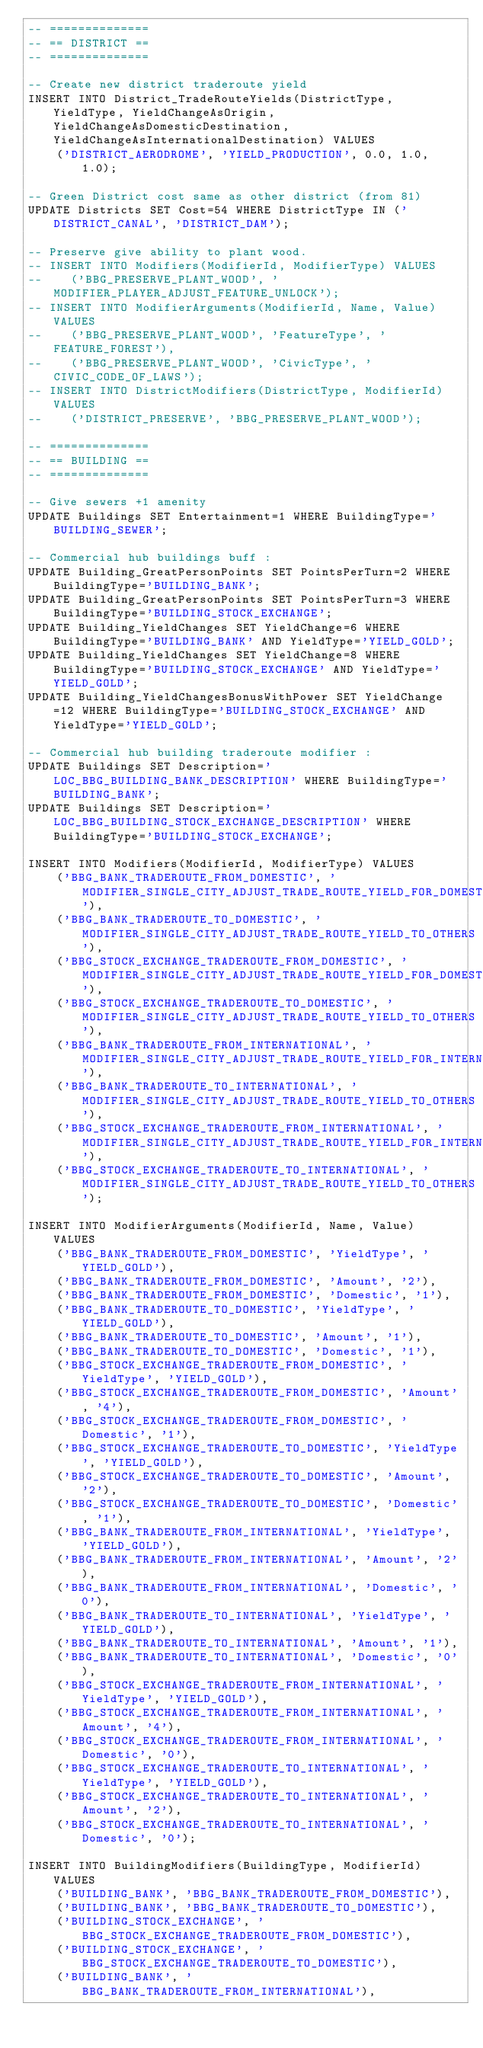<code> <loc_0><loc_0><loc_500><loc_500><_SQL_>-- ==============
-- == DISTRICT ==
-- ==============

-- Create new district traderoute yield
INSERT INTO District_TradeRouteYields(DistrictType, YieldType, YieldChangeAsOrigin, YieldChangeAsDomesticDestination, YieldChangeAsInternationalDestination) VALUES
    ('DISTRICT_AERODROME', 'YIELD_PRODUCTION', 0.0, 1.0, 1.0);

-- Green District cost same as other district (from 81)
UPDATE Districts SET Cost=54 WHERE DistrictType IN ('DISTRICT_CANAL', 'DISTRICT_DAM');

-- Preserve give ability to plant wood.
-- INSERT INTO Modifiers(ModifierId, ModifierType) VALUES
--    ('BBG_PRESERVE_PLANT_WOOD', 'MODIFIER_PLAYER_ADJUST_FEATURE_UNLOCK');
-- INSERT INTO ModifierArguments(ModifierId, Name, Value) VALUES
--    ('BBG_PRESERVE_PLANT_WOOD', 'FeatureType', 'FEATURE_FOREST'),
--    ('BBG_PRESERVE_PLANT_WOOD', 'CivicType', 'CIVIC_CODE_OF_LAWS');
-- INSERT INTO DistrictModifiers(DistrictType, ModifierId) VALUES
--    ('DISTRICT_PRESERVE', 'BBG_PRESERVE_PLANT_WOOD');

-- ==============
-- == BUILDING ==
-- ==============

-- Give sewers +1 amenity
UPDATE Buildings SET Entertainment=1 WHERE BuildingType='BUILDING_SEWER';

-- Commercial hub buildings buff :
UPDATE Building_GreatPersonPoints SET PointsPerTurn=2 WHERE BuildingType='BUILDING_BANK';
UPDATE Building_GreatPersonPoints SET PointsPerTurn=3 WHERE BuildingType='BUILDING_STOCK_EXCHANGE';
UPDATE Building_YieldChanges SET YieldChange=6 WHERE BuildingType='BUILDING_BANK' AND YieldType='YIELD_GOLD';
UPDATE Building_YieldChanges SET YieldChange=8 WHERE BuildingType='BUILDING_STOCK_EXCHANGE' AND YieldType='YIELD_GOLD';
UPDATE Building_YieldChangesBonusWithPower SET YieldChange=12 WHERE BuildingType='BUILDING_STOCK_EXCHANGE' AND YieldType='YIELD_GOLD';

-- Commercial hub building traderoute modifier :
UPDATE Buildings SET Description='LOC_BBG_BUILDING_BANK_DESCRIPTION' WHERE BuildingType='BUILDING_BANK';
UPDATE Buildings SET Description='LOC_BBG_BUILDING_STOCK_EXCHANGE_DESCRIPTION' WHERE BuildingType='BUILDING_STOCK_EXCHANGE';

INSERT INTO Modifiers(ModifierId, ModifierType) VALUES
    ('BBG_BANK_TRADEROUTE_FROM_DOMESTIC', 'MODIFIER_SINGLE_CITY_ADJUST_TRADE_ROUTE_YIELD_FOR_DOMESTIC'),
    ('BBG_BANK_TRADEROUTE_TO_DOMESTIC', 'MODIFIER_SINGLE_CITY_ADJUST_TRADE_ROUTE_YIELD_TO_OTHERS'),
    ('BBG_STOCK_EXCHANGE_TRADEROUTE_FROM_DOMESTIC', 'MODIFIER_SINGLE_CITY_ADJUST_TRADE_ROUTE_YIELD_FOR_DOMESTIC'),
    ('BBG_STOCK_EXCHANGE_TRADEROUTE_TO_DOMESTIC', 'MODIFIER_SINGLE_CITY_ADJUST_TRADE_ROUTE_YIELD_TO_OTHERS'),
    ('BBG_BANK_TRADEROUTE_FROM_INTERNATIONAL', 'MODIFIER_SINGLE_CITY_ADJUST_TRADE_ROUTE_YIELD_FOR_INTERNATIONAL'),
    ('BBG_BANK_TRADEROUTE_TO_INTERNATIONAL', 'MODIFIER_SINGLE_CITY_ADJUST_TRADE_ROUTE_YIELD_TO_OTHERS'),
    ('BBG_STOCK_EXCHANGE_TRADEROUTE_FROM_INTERNATIONAL', 'MODIFIER_SINGLE_CITY_ADJUST_TRADE_ROUTE_YIELD_FOR_INTERNATIONAL'),
    ('BBG_STOCK_EXCHANGE_TRADEROUTE_TO_INTERNATIONAL', 'MODIFIER_SINGLE_CITY_ADJUST_TRADE_ROUTE_YIELD_TO_OTHERS');

INSERT INTO ModifierArguments(ModifierId, Name, Value) VALUES
    ('BBG_BANK_TRADEROUTE_FROM_DOMESTIC', 'YieldType', 'YIELD_GOLD'),
    ('BBG_BANK_TRADEROUTE_FROM_DOMESTIC', 'Amount', '2'),
    ('BBG_BANK_TRADEROUTE_FROM_DOMESTIC', 'Domestic', '1'),
    ('BBG_BANK_TRADEROUTE_TO_DOMESTIC', 'YieldType', 'YIELD_GOLD'),
    ('BBG_BANK_TRADEROUTE_TO_DOMESTIC', 'Amount', '1'),
    ('BBG_BANK_TRADEROUTE_TO_DOMESTIC', 'Domestic', '1'),
    ('BBG_STOCK_EXCHANGE_TRADEROUTE_FROM_DOMESTIC', 'YieldType', 'YIELD_GOLD'),
    ('BBG_STOCK_EXCHANGE_TRADEROUTE_FROM_DOMESTIC', 'Amount', '4'),
    ('BBG_STOCK_EXCHANGE_TRADEROUTE_FROM_DOMESTIC', 'Domestic', '1'),
    ('BBG_STOCK_EXCHANGE_TRADEROUTE_TO_DOMESTIC', 'YieldType', 'YIELD_GOLD'),
    ('BBG_STOCK_EXCHANGE_TRADEROUTE_TO_DOMESTIC', 'Amount', '2'),
    ('BBG_STOCK_EXCHANGE_TRADEROUTE_TO_DOMESTIC', 'Domestic', '1'),
    ('BBG_BANK_TRADEROUTE_FROM_INTERNATIONAL', 'YieldType', 'YIELD_GOLD'),
    ('BBG_BANK_TRADEROUTE_FROM_INTERNATIONAL', 'Amount', '2'),
    ('BBG_BANK_TRADEROUTE_FROM_INTERNATIONAL', 'Domestic', '0'),
    ('BBG_BANK_TRADEROUTE_TO_INTERNATIONAL', 'YieldType', 'YIELD_GOLD'),
    ('BBG_BANK_TRADEROUTE_TO_INTERNATIONAL', 'Amount', '1'),
    ('BBG_BANK_TRADEROUTE_TO_INTERNATIONAL', 'Domestic', '0'),
    ('BBG_STOCK_EXCHANGE_TRADEROUTE_FROM_INTERNATIONAL', 'YieldType', 'YIELD_GOLD'),
    ('BBG_STOCK_EXCHANGE_TRADEROUTE_FROM_INTERNATIONAL', 'Amount', '4'),
    ('BBG_STOCK_EXCHANGE_TRADEROUTE_FROM_INTERNATIONAL', 'Domestic', '0'),
    ('BBG_STOCK_EXCHANGE_TRADEROUTE_TO_INTERNATIONAL', 'YieldType', 'YIELD_GOLD'),
    ('BBG_STOCK_EXCHANGE_TRADEROUTE_TO_INTERNATIONAL', 'Amount', '2'),
    ('BBG_STOCK_EXCHANGE_TRADEROUTE_TO_INTERNATIONAL', 'Domestic', '0');

INSERT INTO BuildingModifiers(BuildingType, ModifierId) VALUES
    ('BUILDING_BANK', 'BBG_BANK_TRADEROUTE_FROM_DOMESTIC'),
    ('BUILDING_BANK', 'BBG_BANK_TRADEROUTE_TO_DOMESTIC'),
    ('BUILDING_STOCK_EXCHANGE', 'BBG_STOCK_EXCHANGE_TRADEROUTE_FROM_DOMESTIC'),
    ('BUILDING_STOCK_EXCHANGE', 'BBG_STOCK_EXCHANGE_TRADEROUTE_TO_DOMESTIC'),
    ('BUILDING_BANK', 'BBG_BANK_TRADEROUTE_FROM_INTERNATIONAL'),</code> 